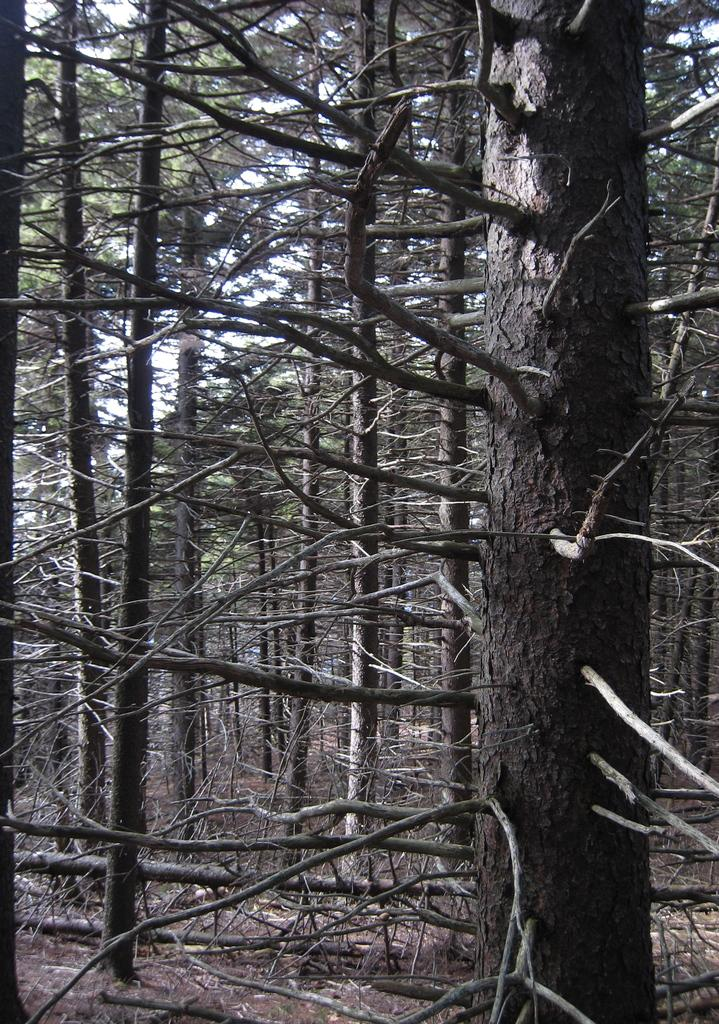What type of vegetation can be seen in the image? There are trees in the image. What is visible at the top of the image? The sky is visible at the top of the image. What type of terrain is visible at the bottom of the image? There is mud visible at the bottom of the image. What type of tin can be seen in the image? There is no tin present in the image. What time of day is it in the image? The time of day cannot be determined from the image, as there are no specific indicators of time. 